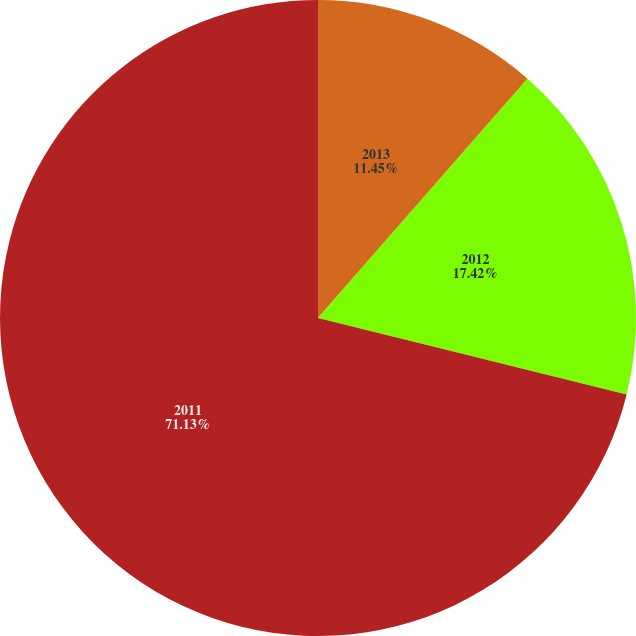<chart> <loc_0><loc_0><loc_500><loc_500><pie_chart><fcel>2013<fcel>2012<fcel>2011<nl><fcel>11.45%<fcel>17.42%<fcel>71.14%<nl></chart> 